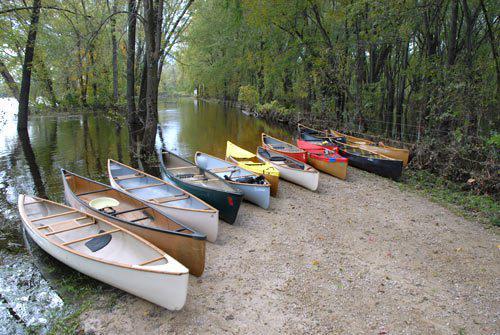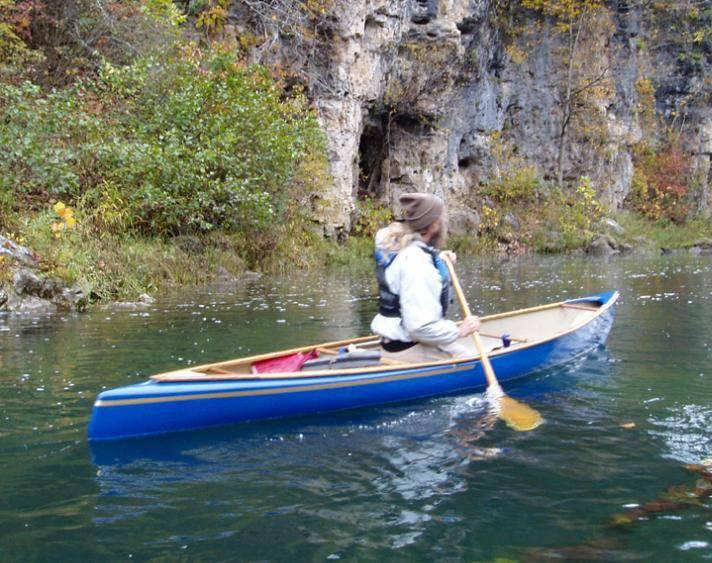The first image is the image on the left, the second image is the image on the right. Considering the images on both sides, is "There are no more than than two people in the image on the right." valid? Answer yes or no. Yes. The first image is the image on the left, the second image is the image on the right. Analyze the images presented: Is the assertion "Two canoes, each with one rider, are present in one image." valid? Answer yes or no. No. 